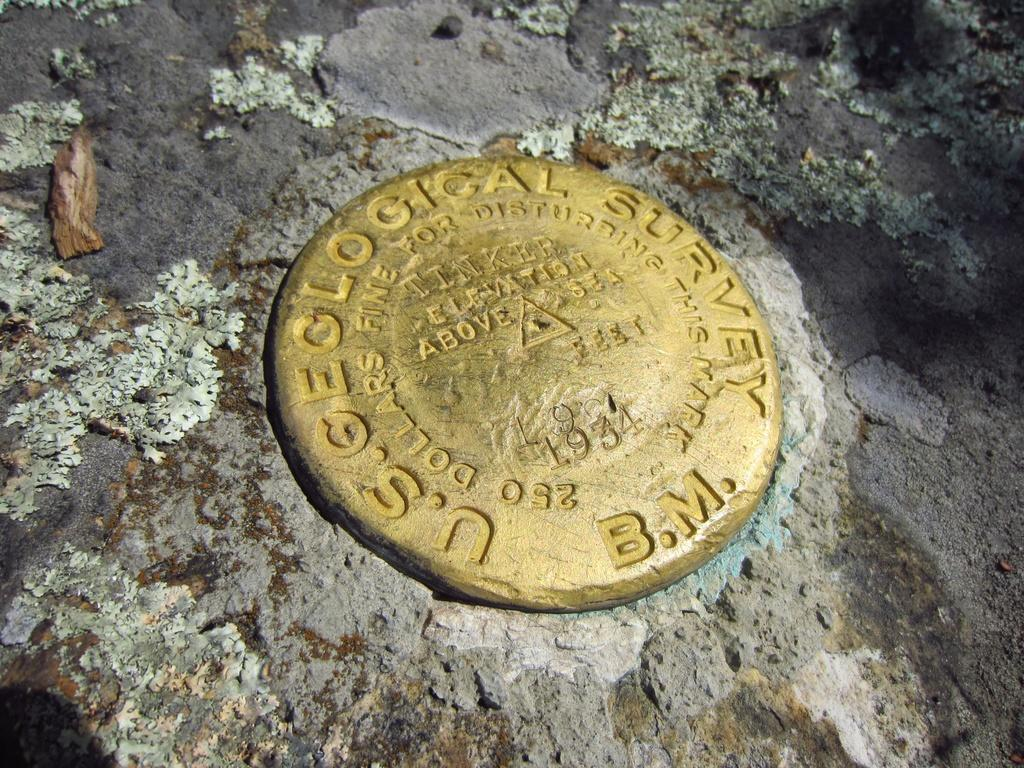<image>
Write a terse but informative summary of the picture. The United States Geological Survey is the owner of the object. 